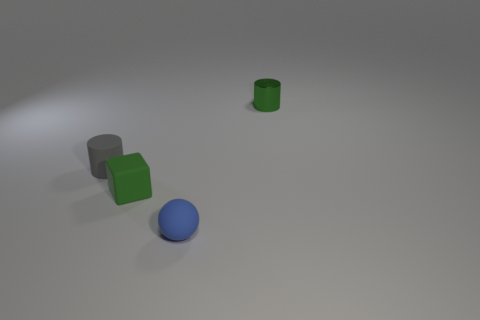Add 2 balls. How many objects exist? 6 Subtract all blocks. How many objects are left? 3 Subtract all green cylinders. Subtract all small gray objects. How many objects are left? 2 Add 3 green cubes. How many green cubes are left? 4 Add 3 blue things. How many blue things exist? 4 Subtract 0 yellow blocks. How many objects are left? 4 